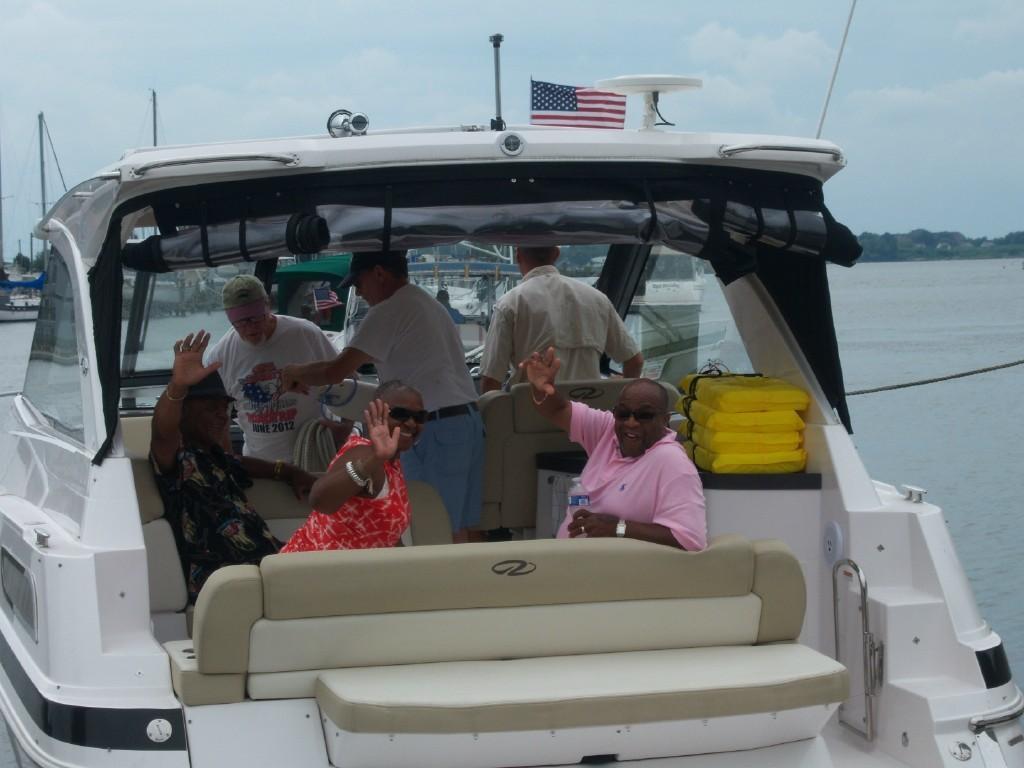Describe this image in one or two sentences. In the image we can see there are people sitting and others are standing in the boat. There is a flag kept on the boat and the boat is standing on the water. Behind there are other boats standing on the water and there is a clear sky. 